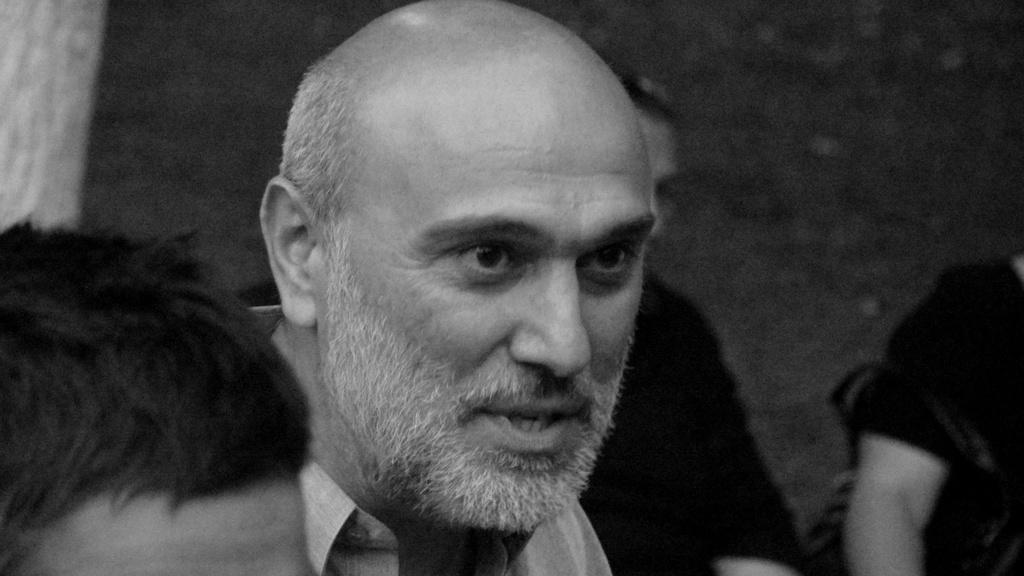What is the appearance of the man in the image? The man in the image has a bald head and beard. How many people are present in the image? There are people in the image. What is the color scheme of the image? The image is black and white. What type of treatment is the man receiving at the farm in the image? There is no farm or treatment present in the image; it features a man with a bald head and beard in a black and white setting. 